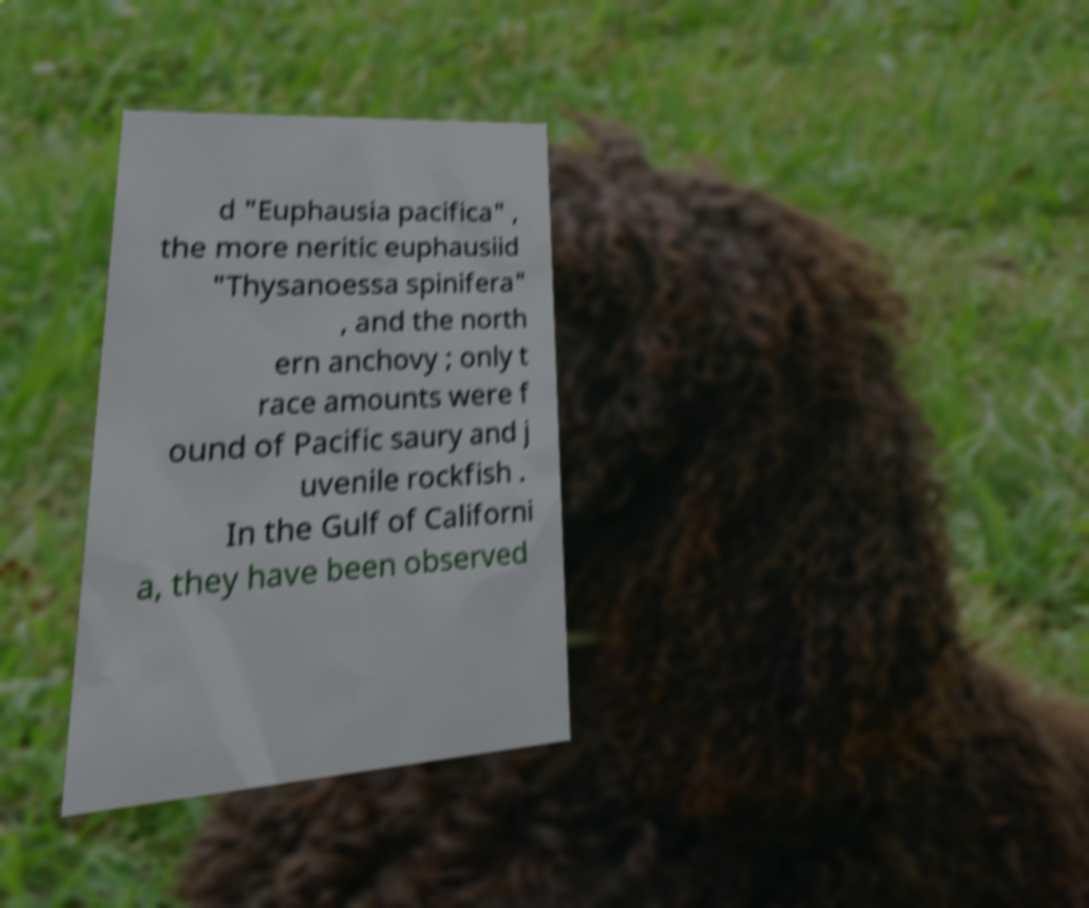There's text embedded in this image that I need extracted. Can you transcribe it verbatim? d "Euphausia pacifica" , the more neritic euphausiid "Thysanoessa spinifera" , and the north ern anchovy ; only t race amounts were f ound of Pacific saury and j uvenile rockfish . In the Gulf of Californi a, they have been observed 